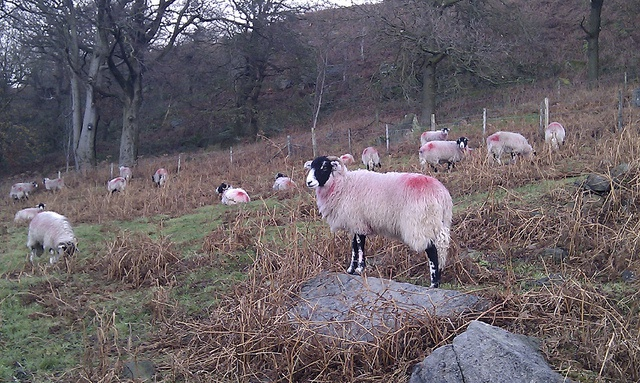Describe the objects in this image and their specific colors. I can see sheep in gray, darkgray, pink, and lavender tones, sheep in gray, darkgray, and lavender tones, sheep in gray, darkgray, lavender, and pink tones, sheep in gray, darkgray, and lavender tones, and sheep in gray tones in this image. 